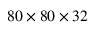<formula> <loc_0><loc_0><loc_500><loc_500>8 0 \times 8 0 \times 3 2</formula> 